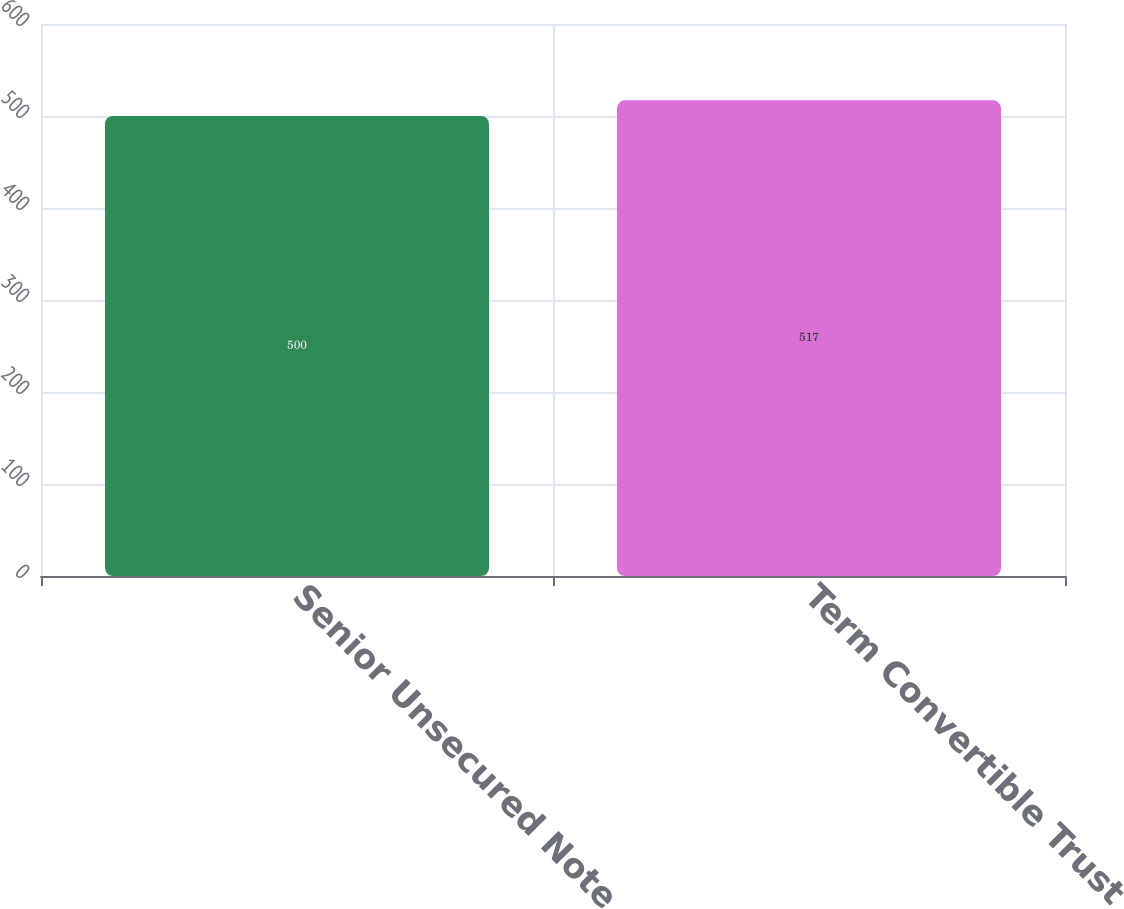Convert chart to OTSL. <chart><loc_0><loc_0><loc_500><loc_500><bar_chart><fcel>Senior Unsecured Note<fcel>Term Convertible Trust<nl><fcel>500<fcel>517<nl></chart> 